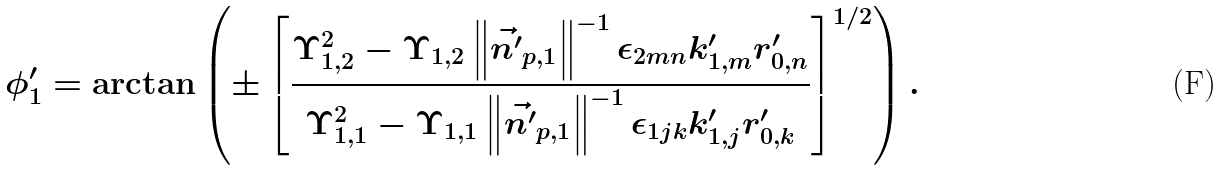<formula> <loc_0><loc_0><loc_500><loc_500>\phi ^ { \prime } _ { 1 } & = \arctan \left ( \pm \left [ \frac { \Upsilon _ { 1 , 2 } ^ { 2 } - \Upsilon _ { 1 , 2 } \left \| \vec { n ^ { \prime } } _ { p , 1 } \right \| ^ { - 1 } \epsilon _ { 2 m n } k ^ { \prime } _ { 1 , m } r ^ { \prime } _ { 0 , n } } { \Upsilon _ { 1 , 1 } ^ { 2 } - \Upsilon _ { 1 , 1 } \left \| \vec { n ^ { \prime } } _ { p , 1 } \right \| ^ { - 1 } \epsilon _ { 1 j k } k ^ { \prime } _ { 1 , j } r ^ { \prime } _ { 0 , k } } \right ] ^ { 1 / 2 } \right ) .</formula> 